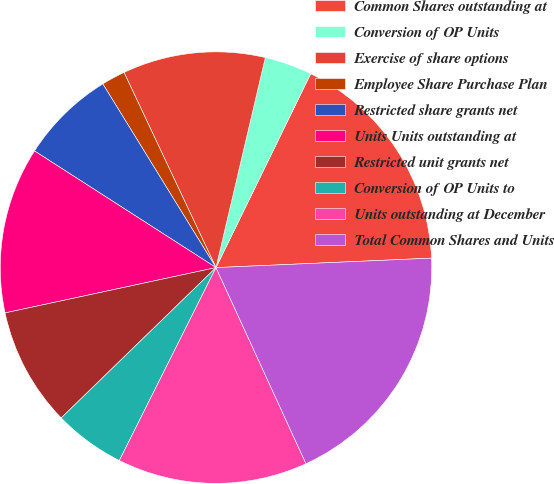Convert chart to OTSL. <chart><loc_0><loc_0><loc_500><loc_500><pie_chart><fcel>Common Shares outstanding at<fcel>Conversion of OP Units<fcel>Exercise of share options<fcel>Employee Share Purchase Plan<fcel>Restricted share grants net<fcel>Units Units outstanding at<fcel>Restricted unit grants net<fcel>Conversion of OP Units to<fcel>Units outstanding at December<fcel>Total Common Shares and Units<nl><fcel>17.07%<fcel>3.56%<fcel>10.68%<fcel>1.78%<fcel>7.12%<fcel>12.46%<fcel>8.9%<fcel>5.34%<fcel>14.24%<fcel>18.85%<nl></chart> 